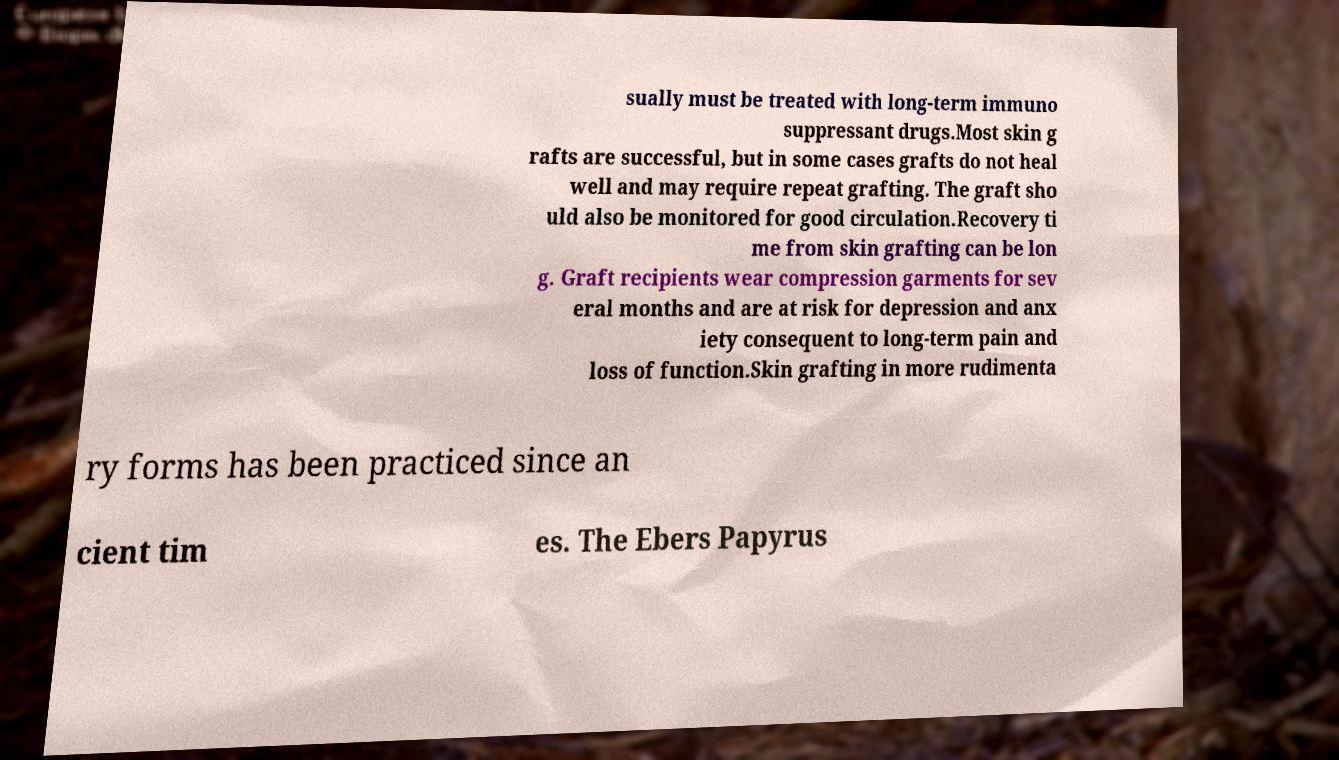Could you assist in decoding the text presented in this image and type it out clearly? sually must be treated with long-term immuno suppressant drugs.Most skin g rafts are successful, but in some cases grafts do not heal well and may require repeat grafting. The graft sho uld also be monitored for good circulation.Recovery ti me from skin grafting can be lon g. Graft recipients wear compression garments for sev eral months and are at risk for depression and anx iety consequent to long-term pain and loss of function.Skin grafting in more rudimenta ry forms has been practiced since an cient tim es. The Ebers Papyrus 